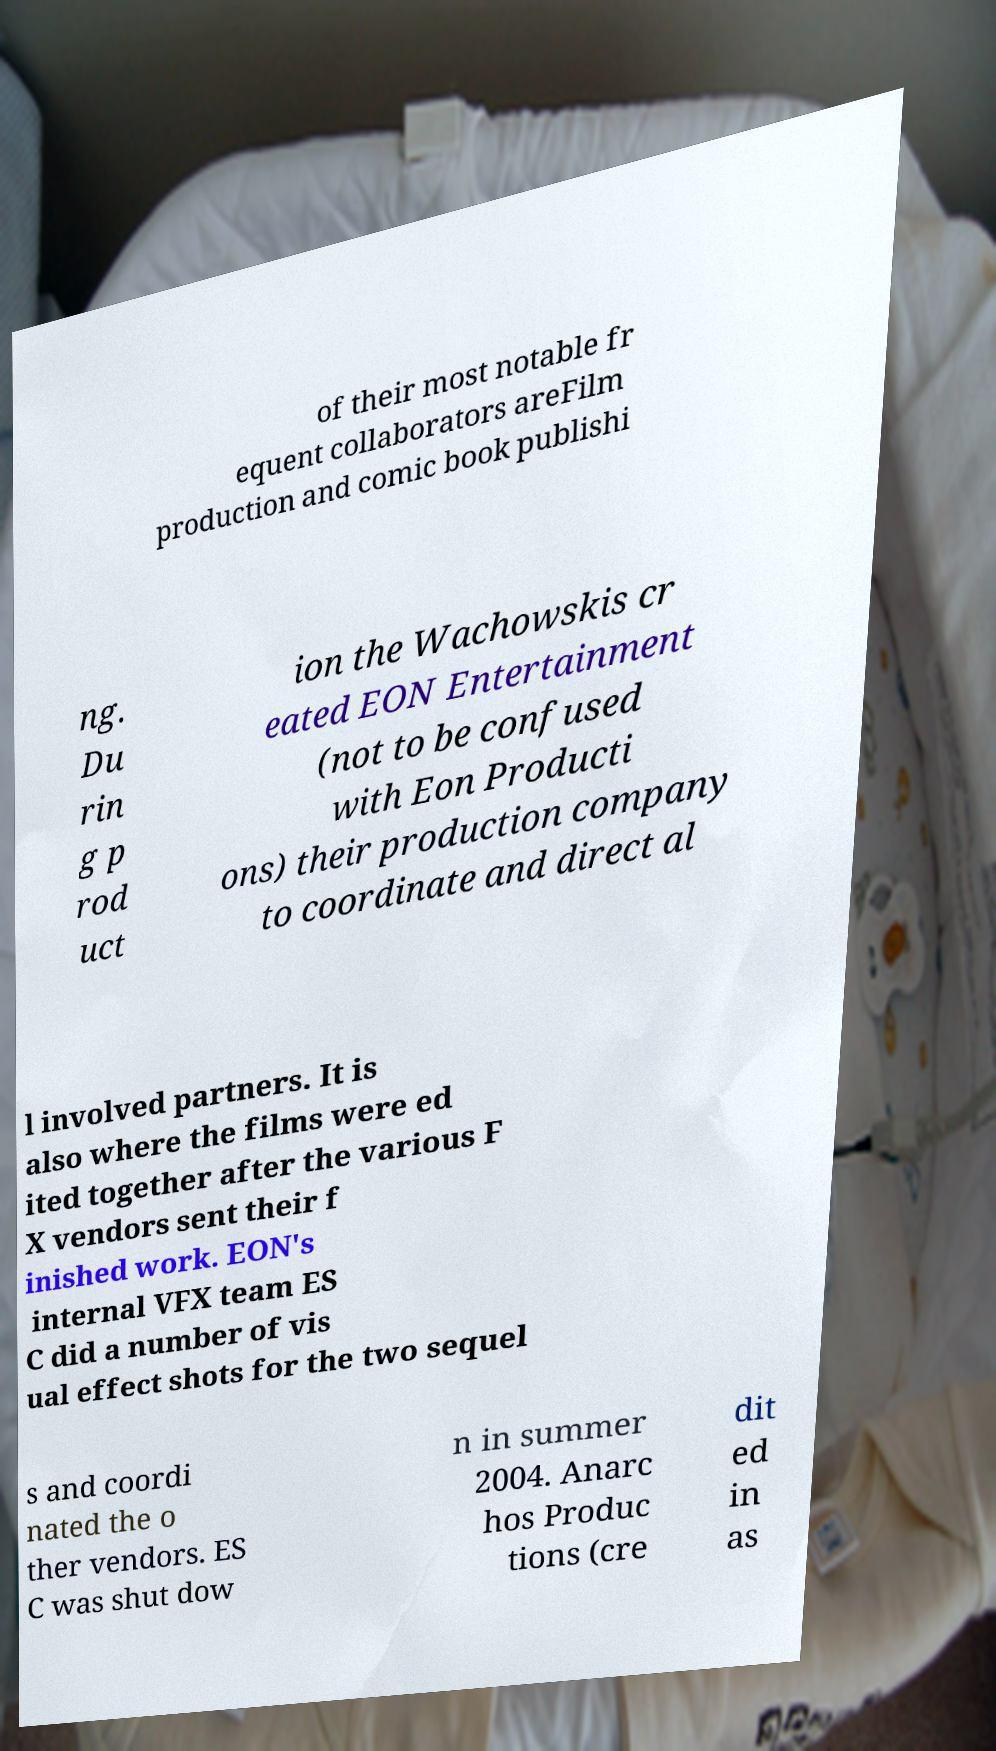For documentation purposes, I need the text within this image transcribed. Could you provide that? of their most notable fr equent collaborators areFilm production and comic book publishi ng. Du rin g p rod uct ion the Wachowskis cr eated EON Entertainment (not to be confused with Eon Producti ons) their production company to coordinate and direct al l involved partners. It is also where the films were ed ited together after the various F X vendors sent their f inished work. EON's internal VFX team ES C did a number of vis ual effect shots for the two sequel s and coordi nated the o ther vendors. ES C was shut dow n in summer 2004. Anarc hos Produc tions (cre dit ed in as 